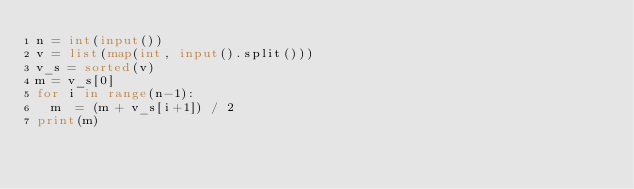Convert code to text. <code><loc_0><loc_0><loc_500><loc_500><_Python_>n = int(input())
v = list(map(int, input().split()))
v_s = sorted(v)
m = v_s[0]
for i in range(n-1):
  m  = (m + v_s[i+1]) / 2
print(m)</code> 